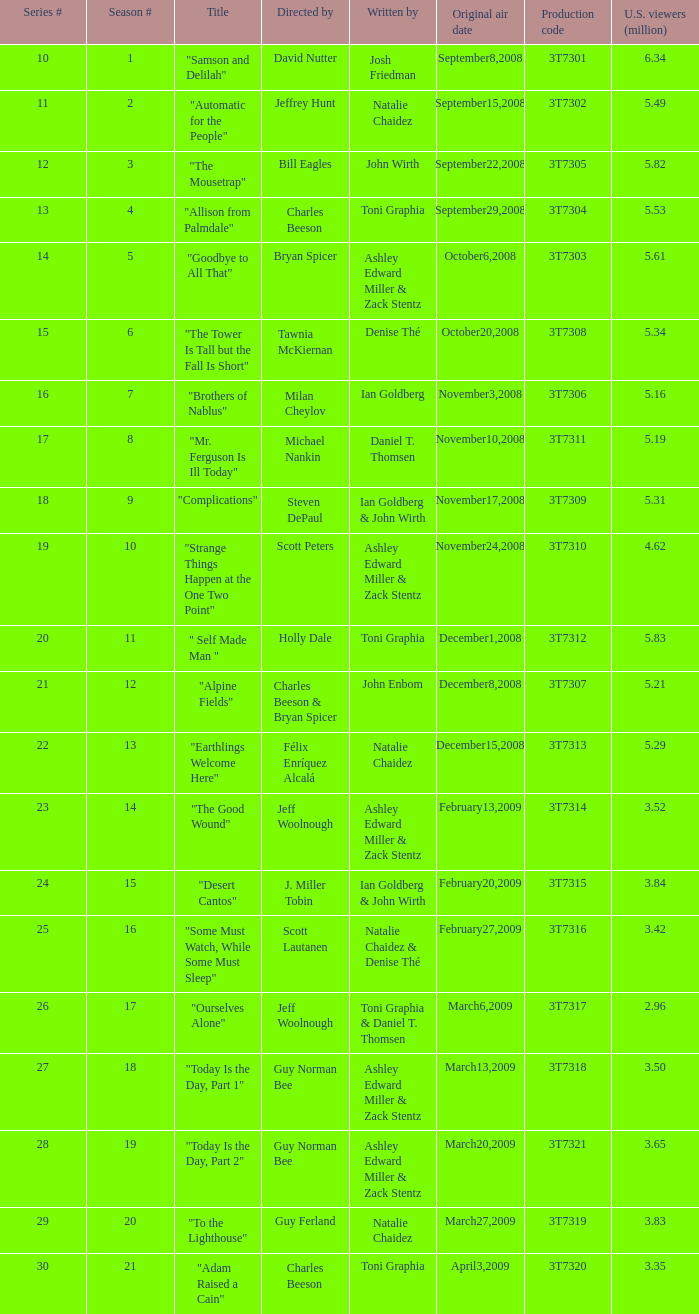How many people watched the episode directed by david nutter? 6.34. 